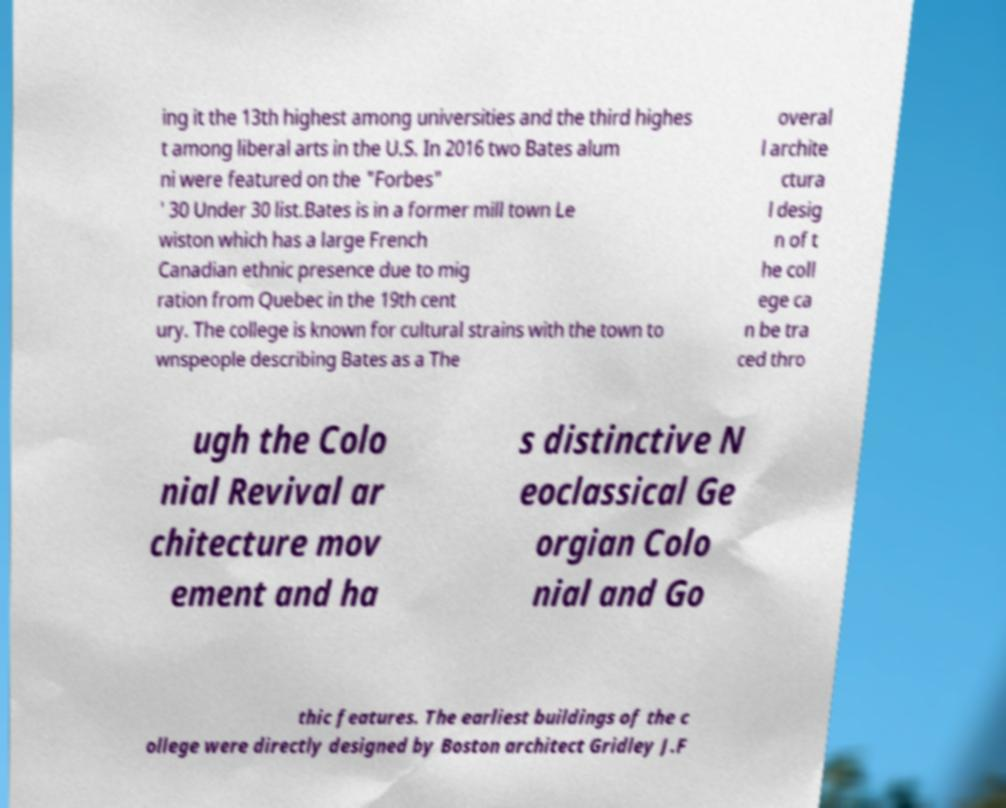Could you assist in decoding the text presented in this image and type it out clearly? ing it the 13th highest among universities and the third highes t among liberal arts in the U.S. In 2016 two Bates alum ni were featured on the "Forbes" ' 30 Under 30 list.Bates is in a former mill town Le wiston which has a large French Canadian ethnic presence due to mig ration from Quebec in the 19th cent ury. The college is known for cultural strains with the town to wnspeople describing Bates as a The overal l archite ctura l desig n of t he coll ege ca n be tra ced thro ugh the Colo nial Revival ar chitecture mov ement and ha s distinctive N eoclassical Ge orgian Colo nial and Go thic features. The earliest buildings of the c ollege were directly designed by Boston architect Gridley J.F 